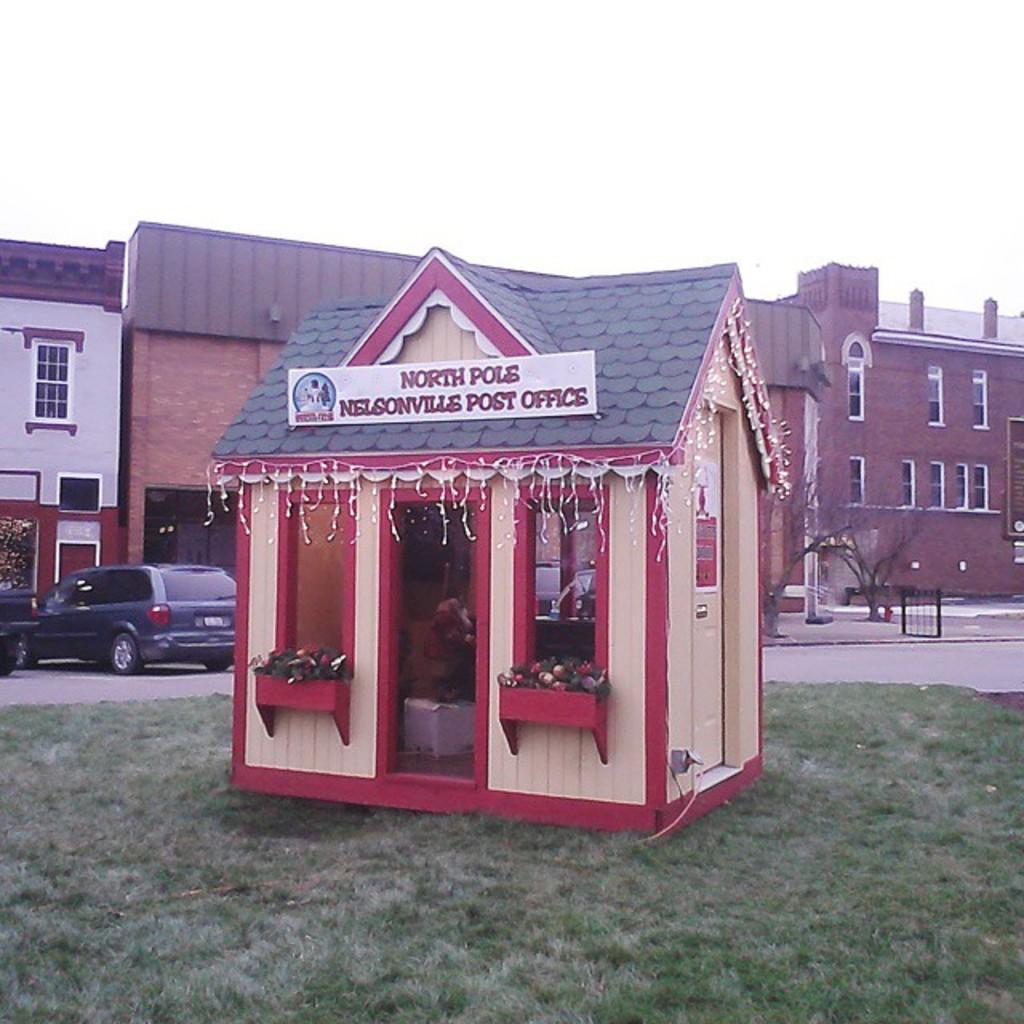Can you describe this image briefly? In this image there are buildings. In the center we can see a shed. On the left there are cars. At the bottom there is grass. In the background there is sky and we can see trees. 